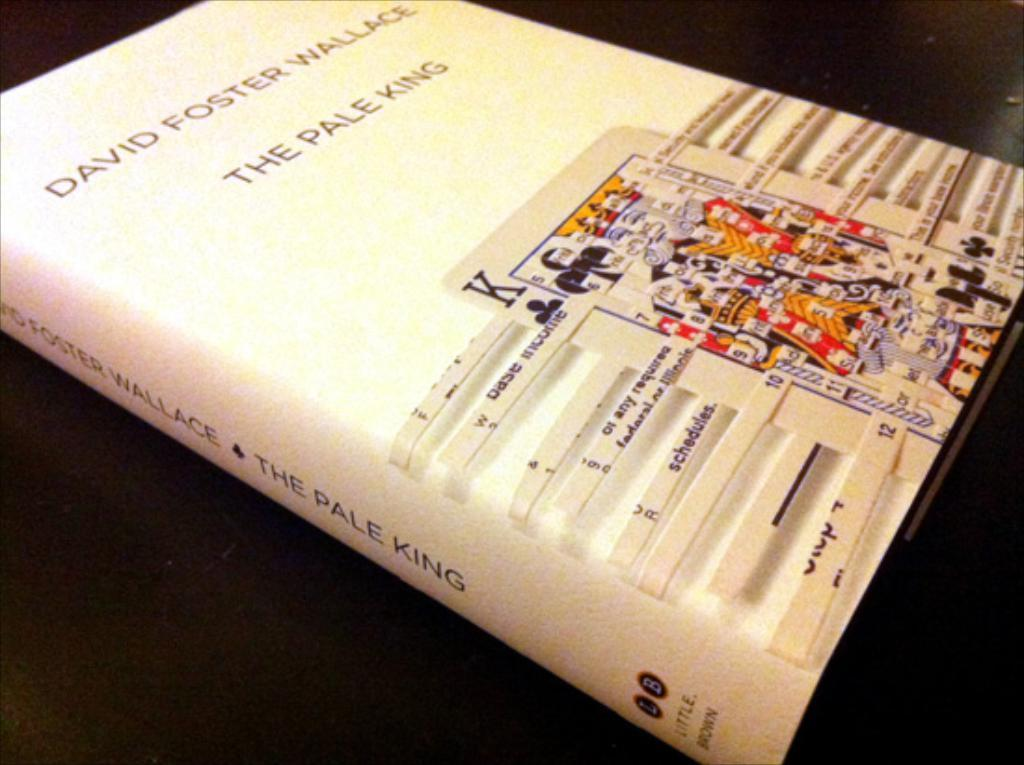What is the color of the surface in the image? The surface in the image is black. What is placed on the black surface? There is a book on the black surface. What is on top of the book? There is an image on top of the book. What can be seen on the image? There is writing on the image. What type of lunch is being served in the image? There is no lunch present in the image; it features a black surface with a book and an image on top. Can you tell me how many eggnogs are visible in the image? There are no eggnogs present in the image. 